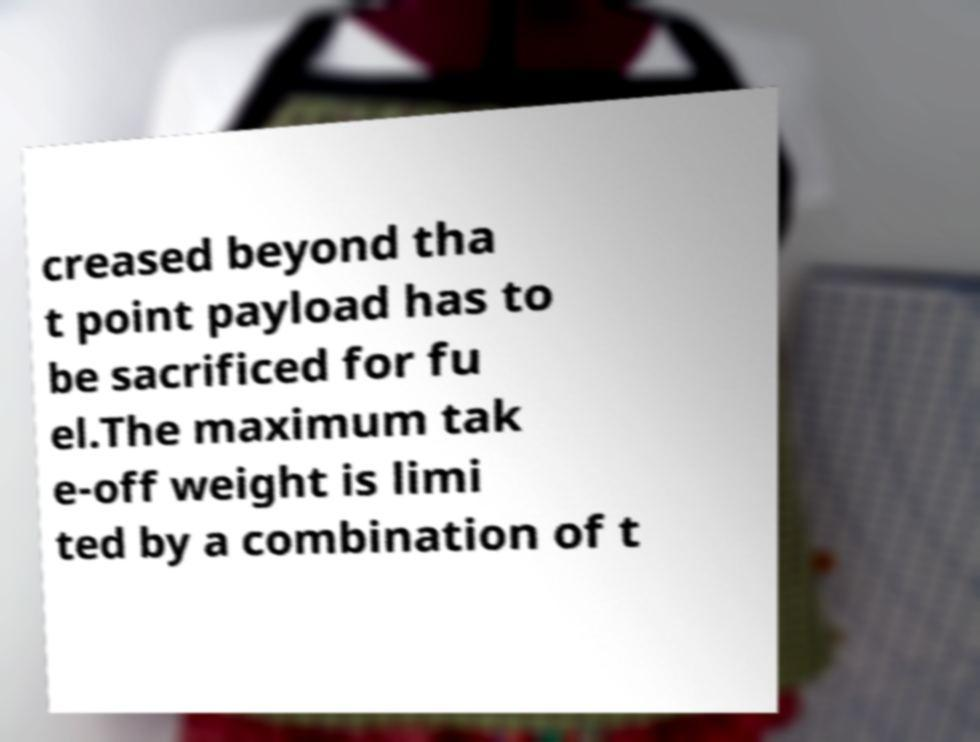Could you assist in decoding the text presented in this image and type it out clearly? creased beyond tha t point payload has to be sacrificed for fu el.The maximum tak e-off weight is limi ted by a combination of t 